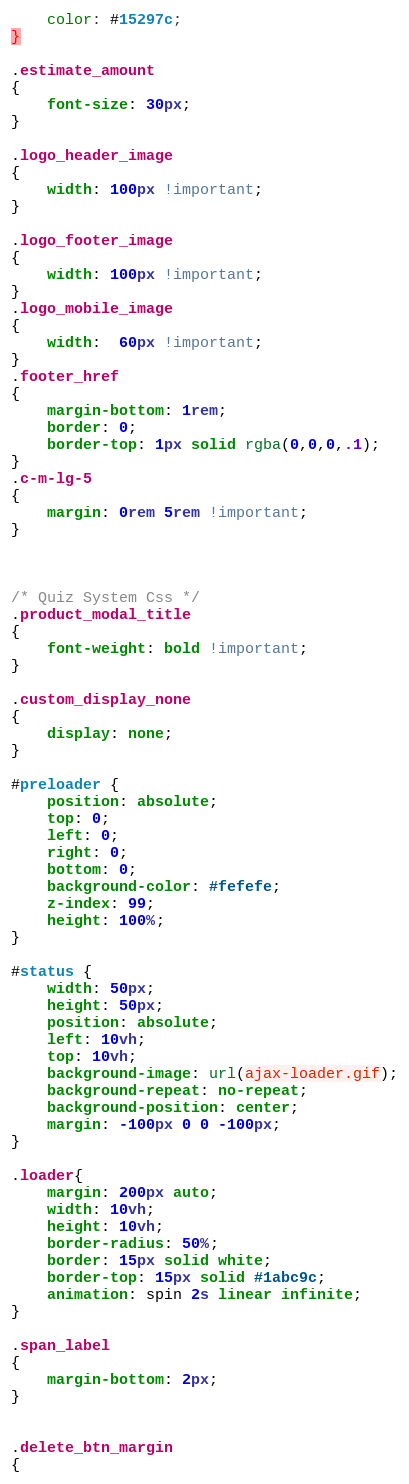Convert code to text. <code><loc_0><loc_0><loc_500><loc_500><_CSS_>    color: #15297c;
}

.estimate_amount
{
	font-size: 30px;
}

.logo_header_image
{
	width: 100px !important;
}

.logo_footer_image
{
	width: 100px !important;
}
.logo_mobile_image
{
	width:  60px !important;
}
.footer_href
{
	margin-bottom: 1rem;
    border: 0;
    border-top: 1px solid rgba(0,0,0,.1);
}
.c-m-lg-5 
{
	margin: 0rem 5rem !important;
}



/* Quiz System Css */
.product_modal_title
{
	font-weight: bold !important;
}

.custom_display_none
{
	display: none;
}

#preloader {
	position: absolute;
	top: 0;
	left: 0;
	right: 0;
	bottom: 0;
	background-color: #fefefe;
	z-index: 99;
	height: 100%;
}
		
#status {
	width: 50px;
	height: 50px;
	position: absolute;
	left: 10vh;
	top: 10vh;
	background-image: url(ajax-loader.gif);
	background-repeat: no-repeat;
	background-position: center;
	margin: -100px 0 0 -100px;
}

.loader{
	margin: 200px auto;
	width: 10vh;
	height: 10vh;
	border-radius: 50%;
	border: 15px solid white;
	border-top: 15px solid #1abc9c;
	animation: spin 2s linear infinite;
}

.span_label
{
	margin-bottom: 2px;
}


.delete_btn_margin
{</code> 